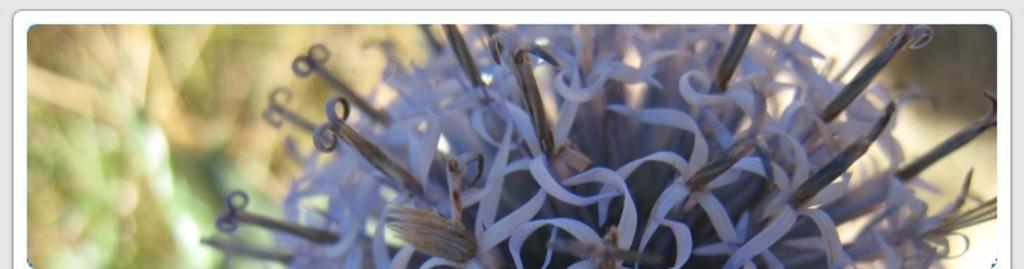What is the main subject of the picture? The main subject of the picture is a flower. Can you describe the color of the flower? The flower is purple in color. What type of offer is being made with the box in the image? There is no box present in the image, and therefore no offer can be made with it. 